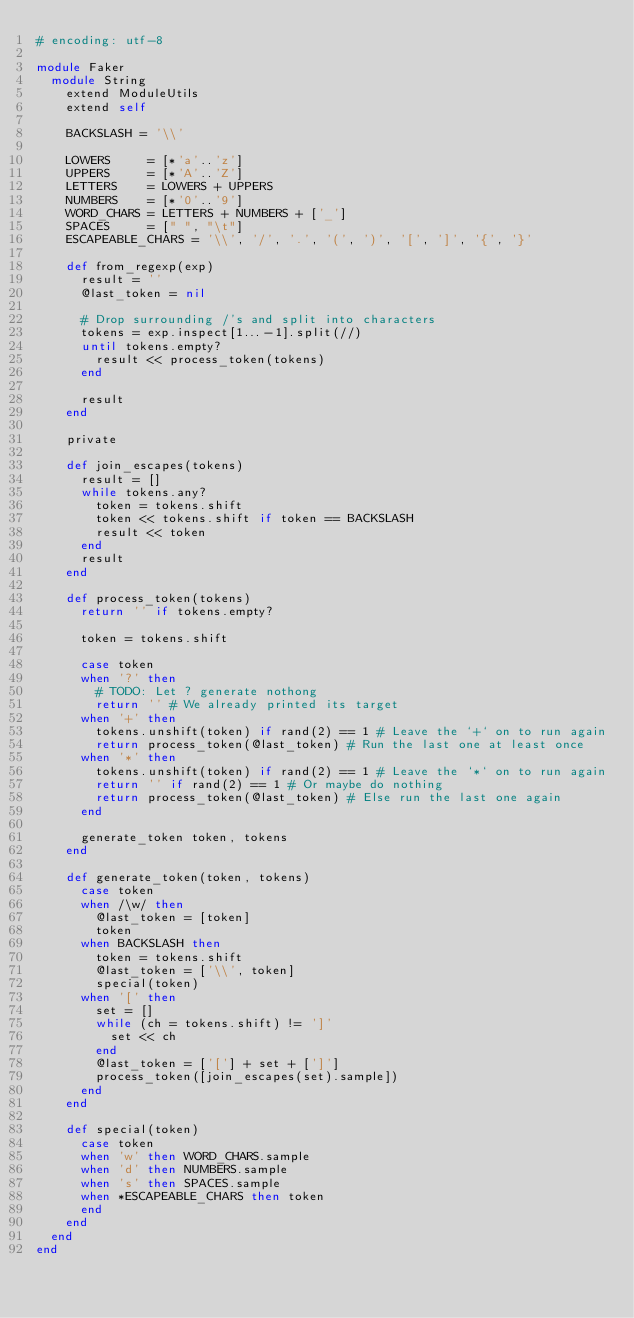<code> <loc_0><loc_0><loc_500><loc_500><_Ruby_># encoding: utf-8

module Faker
  module String
    extend ModuleUtils
    extend self

    BACKSLASH = '\\'

    LOWERS     = [*'a'..'z']
    UPPERS     = [*'A'..'Z']
    LETTERS    = LOWERS + UPPERS
    NUMBERS    = [*'0'..'9']
    WORD_CHARS = LETTERS + NUMBERS + ['_']
    SPACES     = [" ", "\t"]
    ESCAPEABLE_CHARS = '\\', '/', '.', '(', ')', '[', ']', '{', '}'

    def from_regexp(exp)
      result = ''
      @last_token = nil

      # Drop surrounding /'s and split into characters
      tokens = exp.inspect[1...-1].split(//)
      until tokens.empty?
        result << process_token(tokens)
      end

      result
    end

    private

    def join_escapes(tokens)
      result = []
      while tokens.any?
        token = tokens.shift
        token << tokens.shift if token == BACKSLASH
        result << token
      end
      result
    end

    def process_token(tokens)
      return '' if tokens.empty?

      token = tokens.shift

      case token
      when '?' then
        # TODO: Let ? generate nothong
        return '' # We already printed its target
      when '+' then
        tokens.unshift(token) if rand(2) == 1 # Leave the `+` on to run again
        return process_token(@last_token) # Run the last one at least once
      when '*' then
        tokens.unshift(token) if rand(2) == 1 # Leave the `*` on to run again
        return '' if rand(2) == 1 # Or maybe do nothing
        return process_token(@last_token) # Else run the last one again
      end

      generate_token token, tokens
    end

    def generate_token(token, tokens)
      case token
      when /\w/ then
        @last_token = [token]
        token
      when BACKSLASH then
        token = tokens.shift
        @last_token = ['\\', token]
        special(token)
      when '[' then
        set = []
        while (ch = tokens.shift) != ']'
          set << ch
        end
        @last_token = ['['] + set + [']']
        process_token([join_escapes(set).sample])
      end
    end

    def special(token)
      case token
      when 'w' then WORD_CHARS.sample
      when 'd' then NUMBERS.sample
      when 's' then SPACES.sample
      when *ESCAPEABLE_CHARS then token
      end
    end
  end
end
</code> 